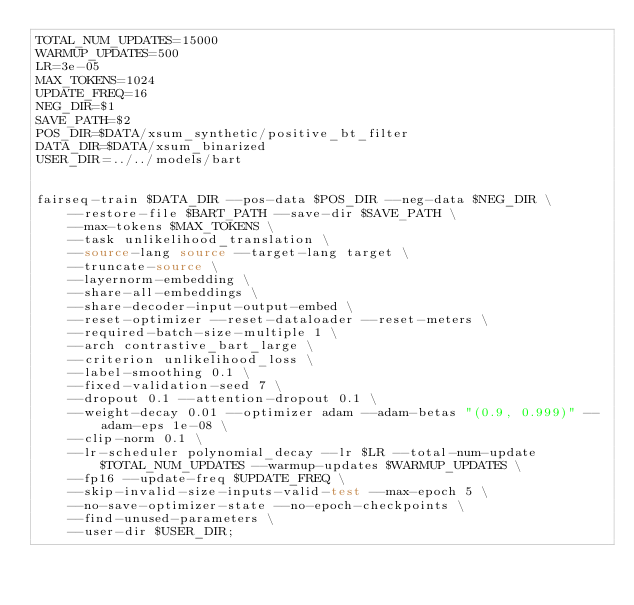Convert code to text. <code><loc_0><loc_0><loc_500><loc_500><_Bash_>TOTAL_NUM_UPDATES=15000
WARMUP_UPDATES=500
LR=3e-05
MAX_TOKENS=1024
UPDATE_FREQ=16
NEG_DIR=$1
SAVE_PATH=$2
POS_DIR=$DATA/xsum_synthetic/positive_bt_filter
DATA_DIR=$DATA/xsum_binarized
USER_DIR=../../models/bart


fairseq-train $DATA_DIR --pos-data $POS_DIR --neg-data $NEG_DIR \
    --restore-file $BART_PATH --save-dir $SAVE_PATH \
    --max-tokens $MAX_TOKENS \
    --task unlikelihood_translation \
    --source-lang source --target-lang target \
    --truncate-source \
    --layernorm-embedding \
    --share-all-embeddings \
    --share-decoder-input-output-embed \
    --reset-optimizer --reset-dataloader --reset-meters \
    --required-batch-size-multiple 1 \
    --arch contrastive_bart_large \
    --criterion unlikelihood_loss \
    --label-smoothing 0.1 \
    --fixed-validation-seed 7 \
    --dropout 0.1 --attention-dropout 0.1 \
    --weight-decay 0.01 --optimizer adam --adam-betas "(0.9, 0.999)" --adam-eps 1e-08 \
    --clip-norm 0.1 \
    --lr-scheduler polynomial_decay --lr $LR --total-num-update $TOTAL_NUM_UPDATES --warmup-updates $WARMUP_UPDATES \
    --fp16 --update-freq $UPDATE_FREQ \
    --skip-invalid-size-inputs-valid-test --max-epoch 5 \
    --no-save-optimizer-state --no-epoch-checkpoints \
    --find-unused-parameters \
    --user-dir $USER_DIR;</code> 